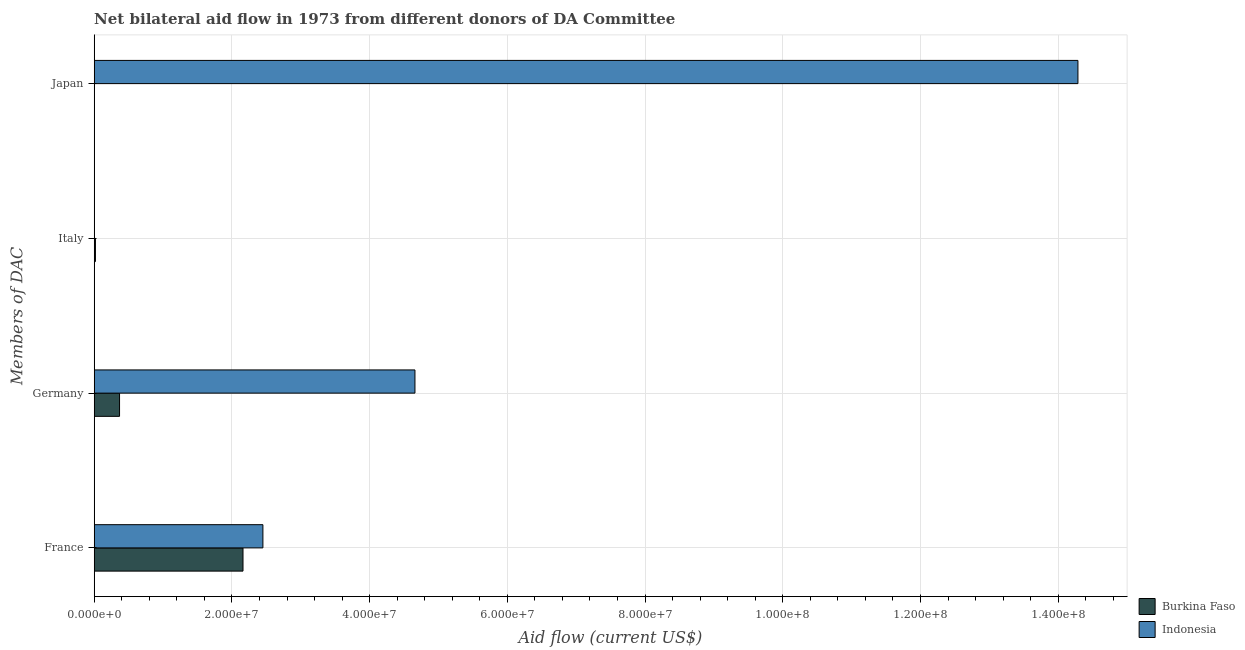How many different coloured bars are there?
Offer a terse response. 2. How many groups of bars are there?
Give a very brief answer. 4. Are the number of bars on each tick of the Y-axis equal?
Your answer should be compact. Yes. What is the amount of aid given by italy in Burkina Faso?
Ensure brevity in your answer.  1.80e+05. Across all countries, what is the maximum amount of aid given by france?
Ensure brevity in your answer.  2.45e+07. Across all countries, what is the minimum amount of aid given by italy?
Give a very brief answer. 2.00e+04. In which country was the amount of aid given by italy maximum?
Your answer should be very brief. Burkina Faso. In which country was the amount of aid given by japan minimum?
Your response must be concise. Burkina Faso. What is the total amount of aid given by japan in the graph?
Your response must be concise. 1.43e+08. What is the difference between the amount of aid given by france in Indonesia and that in Burkina Faso?
Offer a very short reply. 2.89e+06. What is the difference between the amount of aid given by france in Burkina Faso and the amount of aid given by japan in Indonesia?
Provide a succinct answer. -1.21e+08. What is the average amount of aid given by italy per country?
Your answer should be very brief. 1.00e+05. What is the difference between the amount of aid given by germany and amount of aid given by italy in Burkina Faso?
Your response must be concise. 3.50e+06. In how many countries, is the amount of aid given by germany greater than 124000000 US$?
Offer a terse response. 0. What is the ratio of the amount of aid given by japan in Indonesia to that in Burkina Faso?
Give a very brief answer. 1.43e+04. Is the amount of aid given by france in Burkina Faso less than that in Indonesia?
Provide a short and direct response. Yes. What is the difference between the highest and the second highest amount of aid given by france?
Offer a terse response. 2.89e+06. What is the difference between the highest and the lowest amount of aid given by germany?
Your response must be concise. 4.29e+07. In how many countries, is the amount of aid given by italy greater than the average amount of aid given by italy taken over all countries?
Ensure brevity in your answer.  1. Is the sum of the amount of aid given by italy in Indonesia and Burkina Faso greater than the maximum amount of aid given by japan across all countries?
Your answer should be compact. No. What does the 1st bar from the bottom in France represents?
Make the answer very short. Burkina Faso. How many bars are there?
Give a very brief answer. 8. How many countries are there in the graph?
Provide a short and direct response. 2. What is the difference between two consecutive major ticks on the X-axis?
Ensure brevity in your answer.  2.00e+07. Are the values on the major ticks of X-axis written in scientific E-notation?
Offer a terse response. Yes. Does the graph contain any zero values?
Provide a short and direct response. No. What is the title of the graph?
Make the answer very short. Net bilateral aid flow in 1973 from different donors of DA Committee. What is the label or title of the Y-axis?
Offer a very short reply. Members of DAC. What is the Aid flow (current US$) in Burkina Faso in France?
Keep it short and to the point. 2.16e+07. What is the Aid flow (current US$) in Indonesia in France?
Your answer should be compact. 2.45e+07. What is the Aid flow (current US$) of Burkina Faso in Germany?
Offer a terse response. 3.68e+06. What is the Aid flow (current US$) in Indonesia in Germany?
Give a very brief answer. 4.66e+07. What is the Aid flow (current US$) in Burkina Faso in Italy?
Provide a short and direct response. 1.80e+05. What is the Aid flow (current US$) of Indonesia in Italy?
Make the answer very short. 2.00e+04. What is the Aid flow (current US$) of Indonesia in Japan?
Give a very brief answer. 1.43e+08. Across all Members of DAC, what is the maximum Aid flow (current US$) in Burkina Faso?
Ensure brevity in your answer.  2.16e+07. Across all Members of DAC, what is the maximum Aid flow (current US$) of Indonesia?
Your answer should be compact. 1.43e+08. What is the total Aid flow (current US$) in Burkina Faso in the graph?
Give a very brief answer. 2.55e+07. What is the total Aid flow (current US$) of Indonesia in the graph?
Your response must be concise. 2.14e+08. What is the difference between the Aid flow (current US$) in Burkina Faso in France and that in Germany?
Offer a terse response. 1.79e+07. What is the difference between the Aid flow (current US$) of Indonesia in France and that in Germany?
Keep it short and to the point. -2.21e+07. What is the difference between the Aid flow (current US$) of Burkina Faso in France and that in Italy?
Your response must be concise. 2.14e+07. What is the difference between the Aid flow (current US$) in Indonesia in France and that in Italy?
Your answer should be compact. 2.45e+07. What is the difference between the Aid flow (current US$) of Burkina Faso in France and that in Japan?
Ensure brevity in your answer.  2.16e+07. What is the difference between the Aid flow (current US$) of Indonesia in France and that in Japan?
Ensure brevity in your answer.  -1.18e+08. What is the difference between the Aid flow (current US$) of Burkina Faso in Germany and that in Italy?
Offer a terse response. 3.50e+06. What is the difference between the Aid flow (current US$) in Indonesia in Germany and that in Italy?
Give a very brief answer. 4.66e+07. What is the difference between the Aid flow (current US$) in Burkina Faso in Germany and that in Japan?
Give a very brief answer. 3.67e+06. What is the difference between the Aid flow (current US$) of Indonesia in Germany and that in Japan?
Your answer should be very brief. -9.63e+07. What is the difference between the Aid flow (current US$) in Indonesia in Italy and that in Japan?
Make the answer very short. -1.43e+08. What is the difference between the Aid flow (current US$) of Burkina Faso in France and the Aid flow (current US$) of Indonesia in Germany?
Your response must be concise. -2.50e+07. What is the difference between the Aid flow (current US$) of Burkina Faso in France and the Aid flow (current US$) of Indonesia in Italy?
Give a very brief answer. 2.16e+07. What is the difference between the Aid flow (current US$) of Burkina Faso in France and the Aid flow (current US$) of Indonesia in Japan?
Offer a very short reply. -1.21e+08. What is the difference between the Aid flow (current US$) of Burkina Faso in Germany and the Aid flow (current US$) of Indonesia in Italy?
Ensure brevity in your answer.  3.66e+06. What is the difference between the Aid flow (current US$) of Burkina Faso in Germany and the Aid flow (current US$) of Indonesia in Japan?
Ensure brevity in your answer.  -1.39e+08. What is the difference between the Aid flow (current US$) in Burkina Faso in Italy and the Aid flow (current US$) in Indonesia in Japan?
Your response must be concise. -1.43e+08. What is the average Aid flow (current US$) in Burkina Faso per Members of DAC?
Make the answer very short. 6.37e+06. What is the average Aid flow (current US$) in Indonesia per Members of DAC?
Offer a terse response. 5.35e+07. What is the difference between the Aid flow (current US$) of Burkina Faso and Aid flow (current US$) of Indonesia in France?
Your response must be concise. -2.89e+06. What is the difference between the Aid flow (current US$) in Burkina Faso and Aid flow (current US$) in Indonesia in Germany?
Your answer should be very brief. -4.29e+07. What is the difference between the Aid flow (current US$) of Burkina Faso and Aid flow (current US$) of Indonesia in Italy?
Provide a succinct answer. 1.60e+05. What is the difference between the Aid flow (current US$) of Burkina Faso and Aid flow (current US$) of Indonesia in Japan?
Provide a succinct answer. -1.43e+08. What is the ratio of the Aid flow (current US$) of Burkina Faso in France to that in Germany?
Your response must be concise. 5.87. What is the ratio of the Aid flow (current US$) of Indonesia in France to that in Germany?
Give a very brief answer. 0.53. What is the ratio of the Aid flow (current US$) in Burkina Faso in France to that in Italy?
Give a very brief answer. 120.06. What is the ratio of the Aid flow (current US$) of Indonesia in France to that in Italy?
Keep it short and to the point. 1225. What is the ratio of the Aid flow (current US$) in Burkina Faso in France to that in Japan?
Your answer should be compact. 2161. What is the ratio of the Aid flow (current US$) in Indonesia in France to that in Japan?
Provide a short and direct response. 0.17. What is the ratio of the Aid flow (current US$) in Burkina Faso in Germany to that in Italy?
Your response must be concise. 20.44. What is the ratio of the Aid flow (current US$) in Indonesia in Germany to that in Italy?
Ensure brevity in your answer.  2329. What is the ratio of the Aid flow (current US$) in Burkina Faso in Germany to that in Japan?
Offer a terse response. 368. What is the ratio of the Aid flow (current US$) in Indonesia in Germany to that in Japan?
Give a very brief answer. 0.33. What is the difference between the highest and the second highest Aid flow (current US$) in Burkina Faso?
Make the answer very short. 1.79e+07. What is the difference between the highest and the second highest Aid flow (current US$) in Indonesia?
Offer a very short reply. 9.63e+07. What is the difference between the highest and the lowest Aid flow (current US$) in Burkina Faso?
Make the answer very short. 2.16e+07. What is the difference between the highest and the lowest Aid flow (current US$) in Indonesia?
Offer a very short reply. 1.43e+08. 